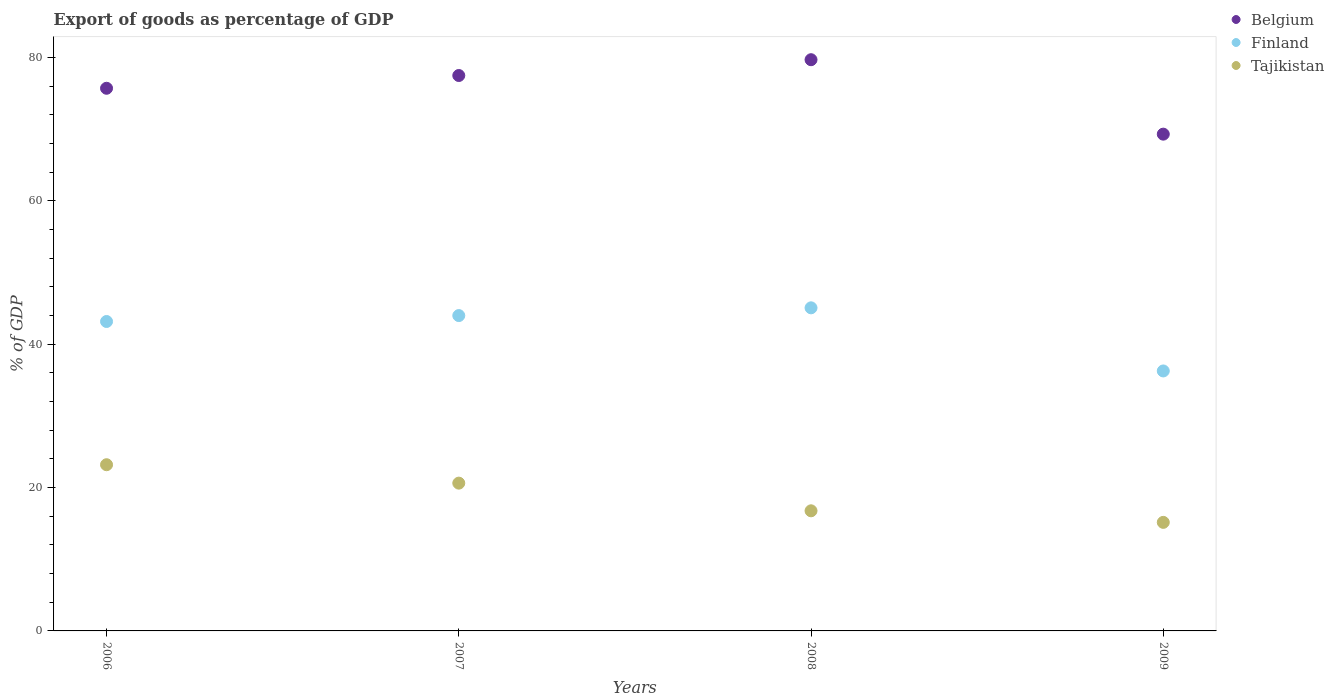How many different coloured dotlines are there?
Give a very brief answer. 3. What is the export of goods as percentage of GDP in Belgium in 2006?
Provide a short and direct response. 75.71. Across all years, what is the maximum export of goods as percentage of GDP in Finland?
Keep it short and to the point. 45.08. Across all years, what is the minimum export of goods as percentage of GDP in Tajikistan?
Ensure brevity in your answer.  15.15. In which year was the export of goods as percentage of GDP in Finland maximum?
Provide a short and direct response. 2008. What is the total export of goods as percentage of GDP in Belgium in the graph?
Ensure brevity in your answer.  302.21. What is the difference between the export of goods as percentage of GDP in Belgium in 2008 and that in 2009?
Your answer should be very brief. 10.39. What is the difference between the export of goods as percentage of GDP in Belgium in 2006 and the export of goods as percentage of GDP in Finland in 2007?
Your answer should be compact. 31.71. What is the average export of goods as percentage of GDP in Tajikistan per year?
Provide a succinct answer. 18.93. In the year 2009, what is the difference between the export of goods as percentage of GDP in Belgium and export of goods as percentage of GDP in Tajikistan?
Offer a very short reply. 54.16. What is the ratio of the export of goods as percentage of GDP in Finland in 2006 to that in 2007?
Ensure brevity in your answer.  0.98. Is the export of goods as percentage of GDP in Finland in 2006 less than that in 2008?
Keep it short and to the point. Yes. What is the difference between the highest and the second highest export of goods as percentage of GDP in Finland?
Ensure brevity in your answer.  1.08. What is the difference between the highest and the lowest export of goods as percentage of GDP in Finland?
Give a very brief answer. 8.81. Is it the case that in every year, the sum of the export of goods as percentage of GDP in Belgium and export of goods as percentage of GDP in Tajikistan  is greater than the export of goods as percentage of GDP in Finland?
Give a very brief answer. Yes. Does the export of goods as percentage of GDP in Finland monotonically increase over the years?
Your answer should be compact. No. How many dotlines are there?
Your answer should be compact. 3. How many years are there in the graph?
Keep it short and to the point. 4. What is the difference between two consecutive major ticks on the Y-axis?
Ensure brevity in your answer.  20. Where does the legend appear in the graph?
Ensure brevity in your answer.  Top right. How many legend labels are there?
Offer a very short reply. 3. What is the title of the graph?
Keep it short and to the point. Export of goods as percentage of GDP. Does "Sudan" appear as one of the legend labels in the graph?
Your answer should be compact. No. What is the label or title of the X-axis?
Make the answer very short. Years. What is the label or title of the Y-axis?
Your response must be concise. % of GDP. What is the % of GDP of Belgium in 2006?
Keep it short and to the point. 75.71. What is the % of GDP in Finland in 2006?
Provide a succinct answer. 43.17. What is the % of GDP in Tajikistan in 2006?
Your response must be concise. 23.19. What is the % of GDP of Belgium in 2007?
Offer a terse response. 77.49. What is the % of GDP in Finland in 2007?
Your answer should be very brief. 44. What is the % of GDP in Tajikistan in 2007?
Give a very brief answer. 20.62. What is the % of GDP of Belgium in 2008?
Ensure brevity in your answer.  79.7. What is the % of GDP of Finland in 2008?
Your answer should be very brief. 45.08. What is the % of GDP in Tajikistan in 2008?
Your answer should be compact. 16.76. What is the % of GDP of Belgium in 2009?
Ensure brevity in your answer.  69.31. What is the % of GDP in Finland in 2009?
Your answer should be compact. 36.27. What is the % of GDP in Tajikistan in 2009?
Ensure brevity in your answer.  15.15. Across all years, what is the maximum % of GDP in Belgium?
Offer a very short reply. 79.7. Across all years, what is the maximum % of GDP of Finland?
Your answer should be very brief. 45.08. Across all years, what is the maximum % of GDP of Tajikistan?
Offer a very short reply. 23.19. Across all years, what is the minimum % of GDP in Belgium?
Keep it short and to the point. 69.31. Across all years, what is the minimum % of GDP of Finland?
Make the answer very short. 36.27. Across all years, what is the minimum % of GDP in Tajikistan?
Your answer should be compact. 15.15. What is the total % of GDP in Belgium in the graph?
Ensure brevity in your answer.  302.21. What is the total % of GDP of Finland in the graph?
Provide a short and direct response. 168.52. What is the total % of GDP in Tajikistan in the graph?
Your answer should be very brief. 75.71. What is the difference between the % of GDP of Belgium in 2006 and that in 2007?
Give a very brief answer. -1.78. What is the difference between the % of GDP of Finland in 2006 and that in 2007?
Your answer should be very brief. -0.83. What is the difference between the % of GDP in Tajikistan in 2006 and that in 2007?
Make the answer very short. 2.57. What is the difference between the % of GDP in Belgium in 2006 and that in 2008?
Provide a short and direct response. -3.98. What is the difference between the % of GDP in Finland in 2006 and that in 2008?
Your response must be concise. -1.91. What is the difference between the % of GDP of Tajikistan in 2006 and that in 2008?
Make the answer very short. 6.43. What is the difference between the % of GDP in Belgium in 2006 and that in 2009?
Make the answer very short. 6.4. What is the difference between the % of GDP of Finland in 2006 and that in 2009?
Provide a short and direct response. 6.9. What is the difference between the % of GDP of Tajikistan in 2006 and that in 2009?
Keep it short and to the point. 8.04. What is the difference between the % of GDP of Belgium in 2007 and that in 2008?
Offer a terse response. -2.21. What is the difference between the % of GDP of Finland in 2007 and that in 2008?
Offer a very short reply. -1.08. What is the difference between the % of GDP in Tajikistan in 2007 and that in 2008?
Provide a succinct answer. 3.86. What is the difference between the % of GDP of Belgium in 2007 and that in 2009?
Ensure brevity in your answer.  8.18. What is the difference between the % of GDP in Finland in 2007 and that in 2009?
Provide a short and direct response. 7.73. What is the difference between the % of GDP of Tajikistan in 2007 and that in 2009?
Offer a very short reply. 5.47. What is the difference between the % of GDP in Belgium in 2008 and that in 2009?
Keep it short and to the point. 10.39. What is the difference between the % of GDP in Finland in 2008 and that in 2009?
Give a very brief answer. 8.81. What is the difference between the % of GDP of Tajikistan in 2008 and that in 2009?
Your answer should be compact. 1.61. What is the difference between the % of GDP in Belgium in 2006 and the % of GDP in Finland in 2007?
Your response must be concise. 31.71. What is the difference between the % of GDP in Belgium in 2006 and the % of GDP in Tajikistan in 2007?
Your answer should be very brief. 55.09. What is the difference between the % of GDP of Finland in 2006 and the % of GDP of Tajikistan in 2007?
Offer a very short reply. 22.55. What is the difference between the % of GDP in Belgium in 2006 and the % of GDP in Finland in 2008?
Your answer should be very brief. 30.63. What is the difference between the % of GDP in Belgium in 2006 and the % of GDP in Tajikistan in 2008?
Your answer should be compact. 58.95. What is the difference between the % of GDP in Finland in 2006 and the % of GDP in Tajikistan in 2008?
Offer a very short reply. 26.41. What is the difference between the % of GDP of Belgium in 2006 and the % of GDP of Finland in 2009?
Offer a very short reply. 39.44. What is the difference between the % of GDP of Belgium in 2006 and the % of GDP of Tajikistan in 2009?
Keep it short and to the point. 60.57. What is the difference between the % of GDP of Finland in 2006 and the % of GDP of Tajikistan in 2009?
Your answer should be compact. 28.03. What is the difference between the % of GDP in Belgium in 2007 and the % of GDP in Finland in 2008?
Offer a terse response. 32.41. What is the difference between the % of GDP in Belgium in 2007 and the % of GDP in Tajikistan in 2008?
Ensure brevity in your answer.  60.73. What is the difference between the % of GDP in Finland in 2007 and the % of GDP in Tajikistan in 2008?
Provide a succinct answer. 27.24. What is the difference between the % of GDP of Belgium in 2007 and the % of GDP of Finland in 2009?
Your answer should be very brief. 41.22. What is the difference between the % of GDP in Belgium in 2007 and the % of GDP in Tajikistan in 2009?
Provide a succinct answer. 62.35. What is the difference between the % of GDP of Finland in 2007 and the % of GDP of Tajikistan in 2009?
Ensure brevity in your answer.  28.85. What is the difference between the % of GDP of Belgium in 2008 and the % of GDP of Finland in 2009?
Offer a terse response. 43.42. What is the difference between the % of GDP in Belgium in 2008 and the % of GDP in Tajikistan in 2009?
Your answer should be compact. 64.55. What is the difference between the % of GDP of Finland in 2008 and the % of GDP of Tajikistan in 2009?
Provide a short and direct response. 29.93. What is the average % of GDP of Belgium per year?
Your answer should be compact. 75.55. What is the average % of GDP of Finland per year?
Your response must be concise. 42.13. What is the average % of GDP of Tajikistan per year?
Provide a short and direct response. 18.93. In the year 2006, what is the difference between the % of GDP of Belgium and % of GDP of Finland?
Provide a short and direct response. 32.54. In the year 2006, what is the difference between the % of GDP of Belgium and % of GDP of Tajikistan?
Your answer should be compact. 52.52. In the year 2006, what is the difference between the % of GDP in Finland and % of GDP in Tajikistan?
Offer a very short reply. 19.98. In the year 2007, what is the difference between the % of GDP of Belgium and % of GDP of Finland?
Your response must be concise. 33.49. In the year 2007, what is the difference between the % of GDP in Belgium and % of GDP in Tajikistan?
Your answer should be very brief. 56.87. In the year 2007, what is the difference between the % of GDP in Finland and % of GDP in Tajikistan?
Make the answer very short. 23.38. In the year 2008, what is the difference between the % of GDP in Belgium and % of GDP in Finland?
Ensure brevity in your answer.  34.62. In the year 2008, what is the difference between the % of GDP of Belgium and % of GDP of Tajikistan?
Provide a succinct answer. 62.94. In the year 2008, what is the difference between the % of GDP in Finland and % of GDP in Tajikistan?
Your response must be concise. 28.32. In the year 2009, what is the difference between the % of GDP of Belgium and % of GDP of Finland?
Your answer should be very brief. 33.04. In the year 2009, what is the difference between the % of GDP of Belgium and % of GDP of Tajikistan?
Your response must be concise. 54.16. In the year 2009, what is the difference between the % of GDP of Finland and % of GDP of Tajikistan?
Offer a terse response. 21.13. What is the ratio of the % of GDP of Belgium in 2006 to that in 2007?
Make the answer very short. 0.98. What is the ratio of the % of GDP of Finland in 2006 to that in 2007?
Give a very brief answer. 0.98. What is the ratio of the % of GDP of Tajikistan in 2006 to that in 2007?
Make the answer very short. 1.12. What is the ratio of the % of GDP in Finland in 2006 to that in 2008?
Your response must be concise. 0.96. What is the ratio of the % of GDP in Tajikistan in 2006 to that in 2008?
Offer a terse response. 1.38. What is the ratio of the % of GDP in Belgium in 2006 to that in 2009?
Your answer should be very brief. 1.09. What is the ratio of the % of GDP of Finland in 2006 to that in 2009?
Make the answer very short. 1.19. What is the ratio of the % of GDP in Tajikistan in 2006 to that in 2009?
Provide a short and direct response. 1.53. What is the ratio of the % of GDP of Belgium in 2007 to that in 2008?
Your answer should be compact. 0.97. What is the ratio of the % of GDP of Finland in 2007 to that in 2008?
Give a very brief answer. 0.98. What is the ratio of the % of GDP in Tajikistan in 2007 to that in 2008?
Make the answer very short. 1.23. What is the ratio of the % of GDP in Belgium in 2007 to that in 2009?
Your response must be concise. 1.12. What is the ratio of the % of GDP in Finland in 2007 to that in 2009?
Your response must be concise. 1.21. What is the ratio of the % of GDP of Tajikistan in 2007 to that in 2009?
Your answer should be compact. 1.36. What is the ratio of the % of GDP of Belgium in 2008 to that in 2009?
Your response must be concise. 1.15. What is the ratio of the % of GDP in Finland in 2008 to that in 2009?
Offer a very short reply. 1.24. What is the ratio of the % of GDP in Tajikistan in 2008 to that in 2009?
Provide a succinct answer. 1.11. What is the difference between the highest and the second highest % of GDP in Belgium?
Ensure brevity in your answer.  2.21. What is the difference between the highest and the second highest % of GDP in Finland?
Your answer should be compact. 1.08. What is the difference between the highest and the second highest % of GDP of Tajikistan?
Offer a very short reply. 2.57. What is the difference between the highest and the lowest % of GDP in Belgium?
Your answer should be very brief. 10.39. What is the difference between the highest and the lowest % of GDP in Finland?
Your answer should be compact. 8.81. What is the difference between the highest and the lowest % of GDP in Tajikistan?
Your answer should be very brief. 8.04. 